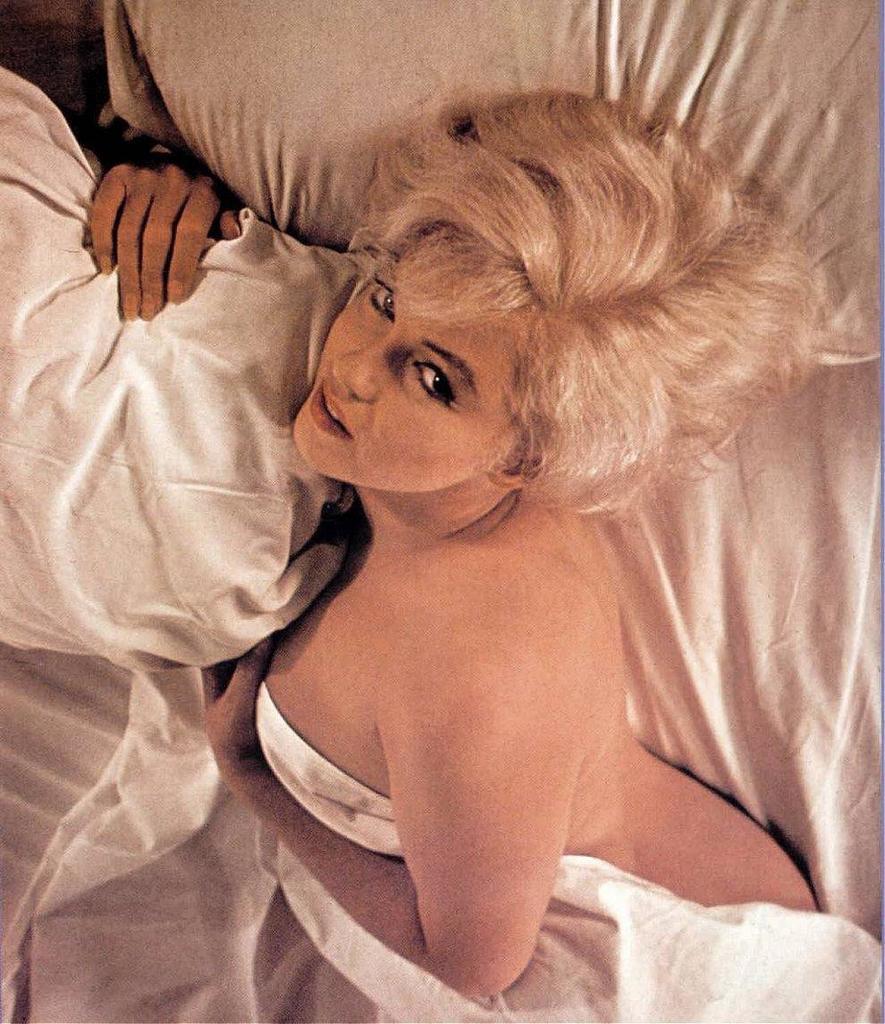Could you give a brief overview of what you see in this image? In this image there a woman laying on bed, on the bed there are two pillows visible on the bed. 